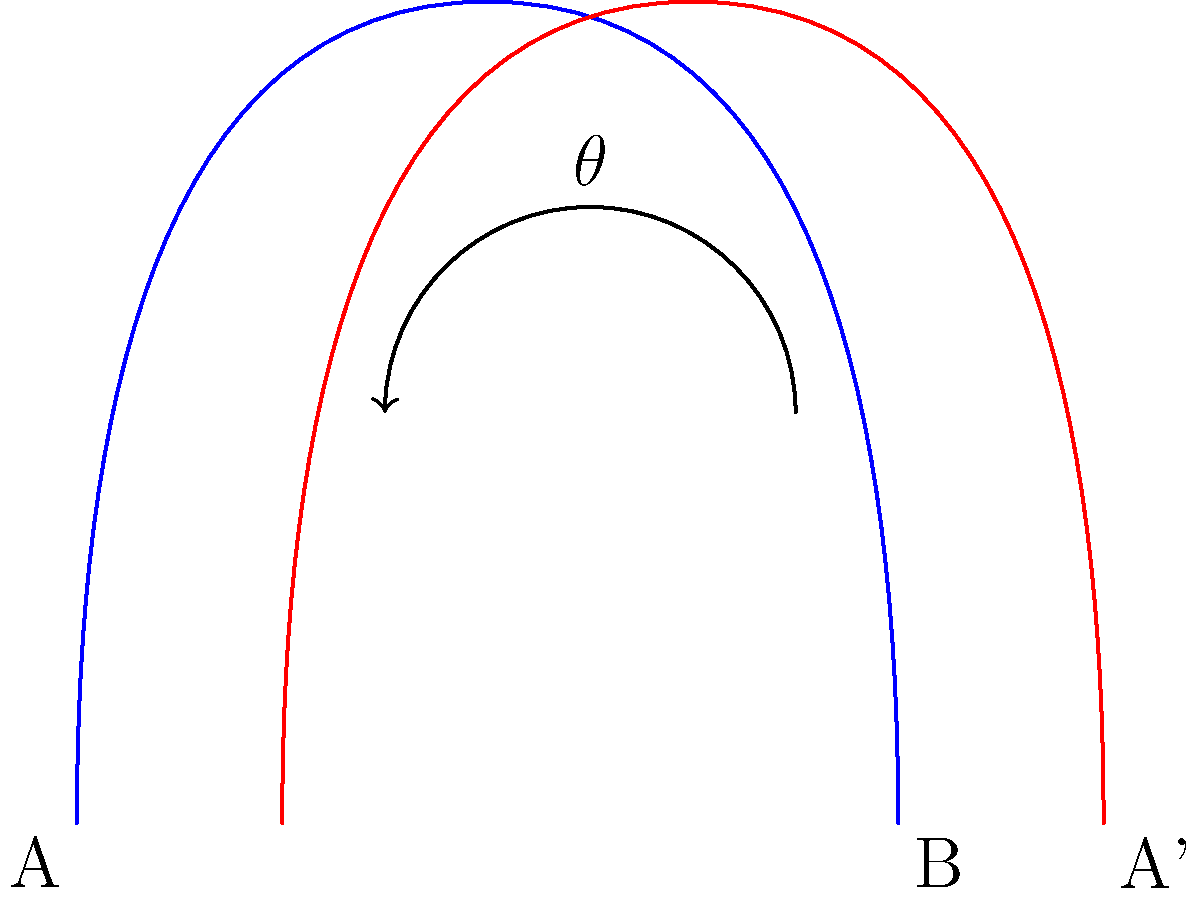A DNA helix needs to be rotated to align specific genetic sequences. If point A on the helix is initially at (0,0) and point B is at (2,0), and after rotation point A moves to (2.5,0), what is the angle of rotation $\theta$ (in degrees) required to achieve this alignment? To solve this problem, we'll use the concept of rotation in the complex plane:

1) First, we need to represent the points as complex numbers:
   A = 0 + 0i
   B = 2 + 0i
   A' (rotated A) = 2.5 + 0i

2) The rotation of a point z by an angle $\theta$ is given by the formula:
   $z' = z \cdot e^{i\theta}$

3) In our case, we're rotating A to A', so:
   $2.5 = 0 \cdot e^{i\theta}$

4) This doesn't give us useful information, so let's consider the relative positions:
   Vector AB = 2 + 0i
   Vector AA' = 2.5 + 0i

5) The rotation that takes AB to AA' is what we're looking for. We can find this by dividing AA' by AB:
   $\frac{AA'}{AB} = \frac{2.5}{2} = 1.25 = e^{i\theta}$

6) To find $\theta$, we take the argument (angle) of this complex number:
   $\theta = \arg(1.25) = \arccos(1.25)$

7) Calculate this in radians:
   $\theta = \arccos(1.25) \approx 0$

8) Convert to degrees:
   $\theta \approx 0°$

The angle is approximately 0° because 1.25 is a real number greater than 1, which corresponds to a scaling rather than a rotation in the complex plane.
Answer: 0° 